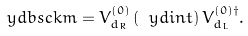Convert formula to latex. <formula><loc_0><loc_0><loc_500><loc_500>\ y d b s c k m = V _ { d _ { R } } ^ { ( 0 ) } \left ( \ y d i n t \right ) V _ { d _ { L } } ^ { ( 0 ) \dag } .</formula> 